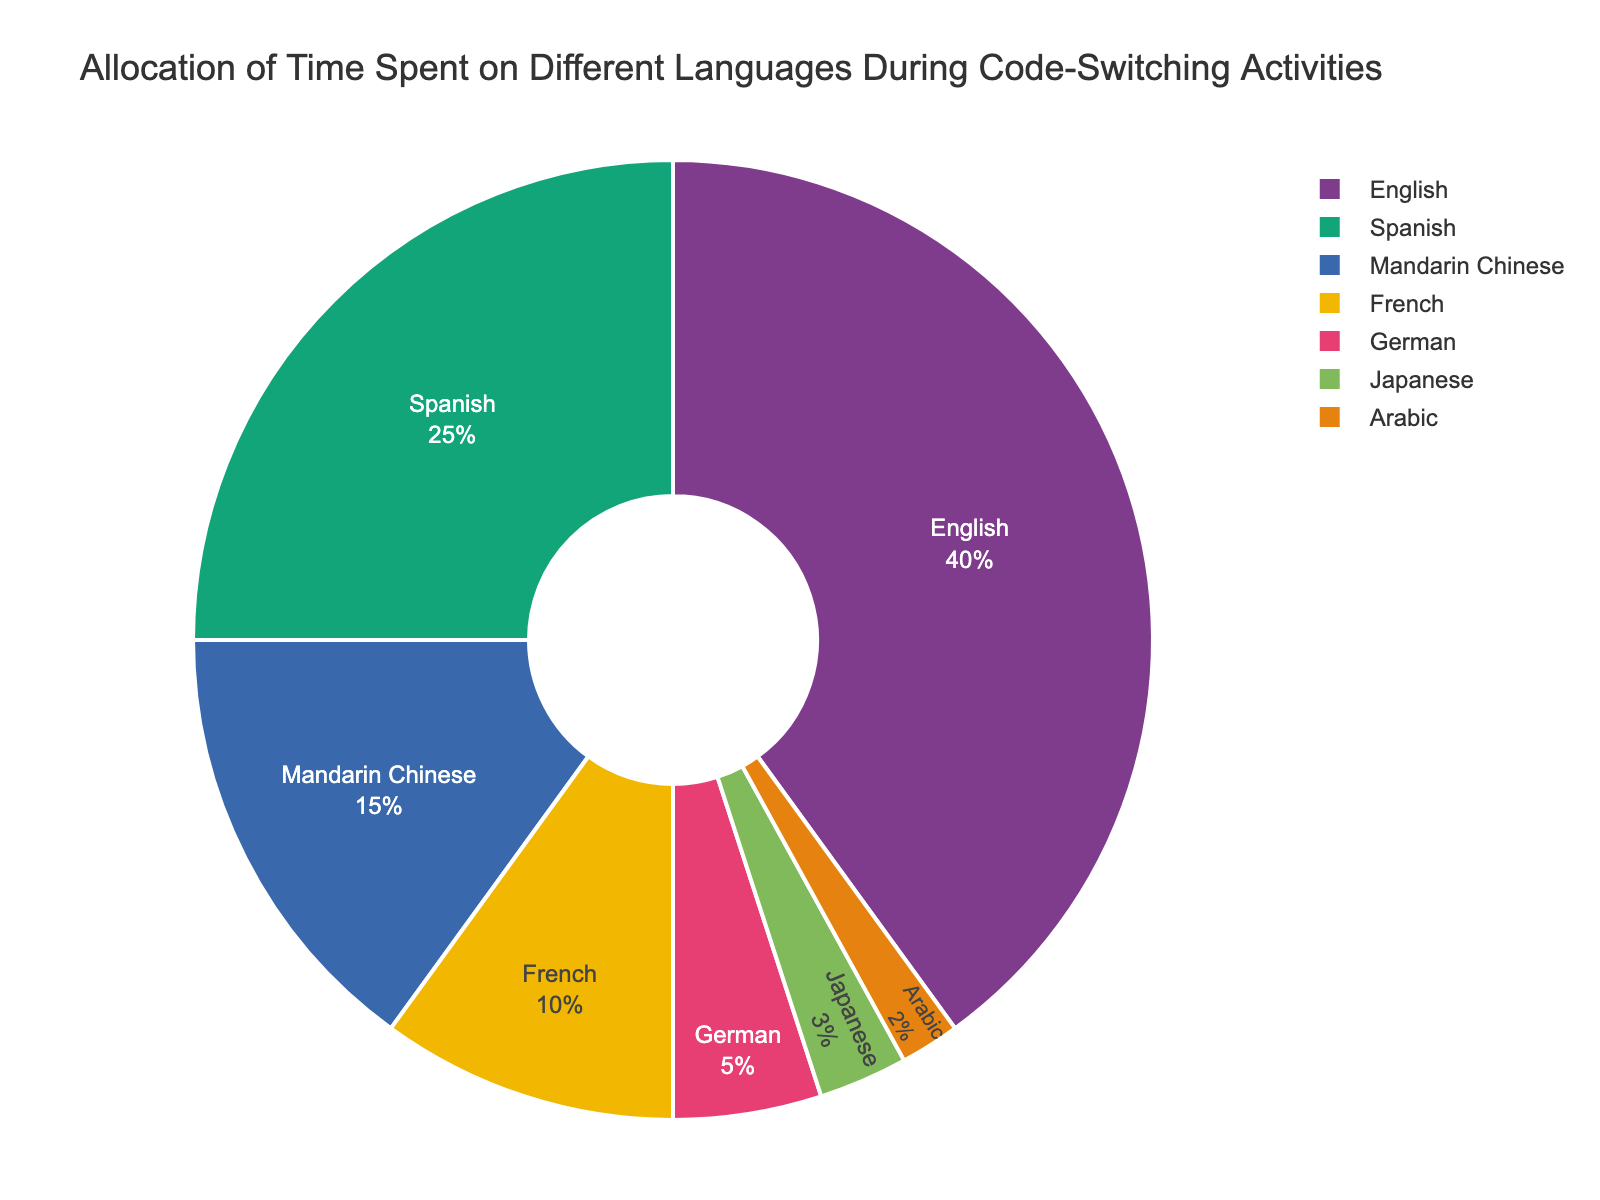Which language occupies the largest portion of time in code-switching activities? Observe the pie chart and look for the language segment that constitutes the largest percentage. English occupies 40% of the chart, the highest percentage among all the languages.
Answer: English What percentage of the time is spent on the three least used languages combined? Identify the percentages of the three least used languages (Japanese, Arabic, German) and sum them up: 3% (Japanese) + 2% (Arabic) + 5% (German) = 10%.
Answer: 10% How much more time is spent on English compared to Mandarin Chinese? Find the percentages for English and Mandarin Chinese and calculate the difference: 40% (English) - 15% (Mandarin Chinese) = 25%.
Answer: 25% Which language has a higher percentage allocation, French or German? Observe the pie chart to compare French and German segments. French has 10% while German has 5%, so French has a higher percentage.
Answer: French What is the difference in percentage allocation between Spanish and Mandarin Chinese? Identify the percentages for Spanish and Mandarin Chinese and find the difference: 25% (Spanish) - 15% (Mandarin Chinese) = 10%.
Answer: 10% Which language occupies the smallest portion of time in the activities? Look for the language segment with the smallest percentage on the pie chart. Arabic occupies 2% of the chart, the smallest percentage.
Answer: Arabic By how much does the percentage allocation of Spanish exceed that of Japanese? Compare the percentages for Spanish and Japanese and calculate the excess: 25% (Spanish) - 3% (Japanese) = 22%.
Answer: 22% Are there more or less than 50% of activities spent on English and Spanish combined? Sum the percentages for English and Spanish: 40% (English) + 25% (Spanish) = 65%, which is more than 50%.
Answer: More Which occupies a greater percentage of the time, Mandarin Chinese or the combined time of Japanese and Arabic? Determine the individual percentages and compare: Mandarin Chinese is 15%. Combined Japanese and Arabic is 3% (Japanese) + 2% (Arabic) = 5%. Mandarin Chinese occupies a greater percentage.
Answer: Mandarin Chinese 